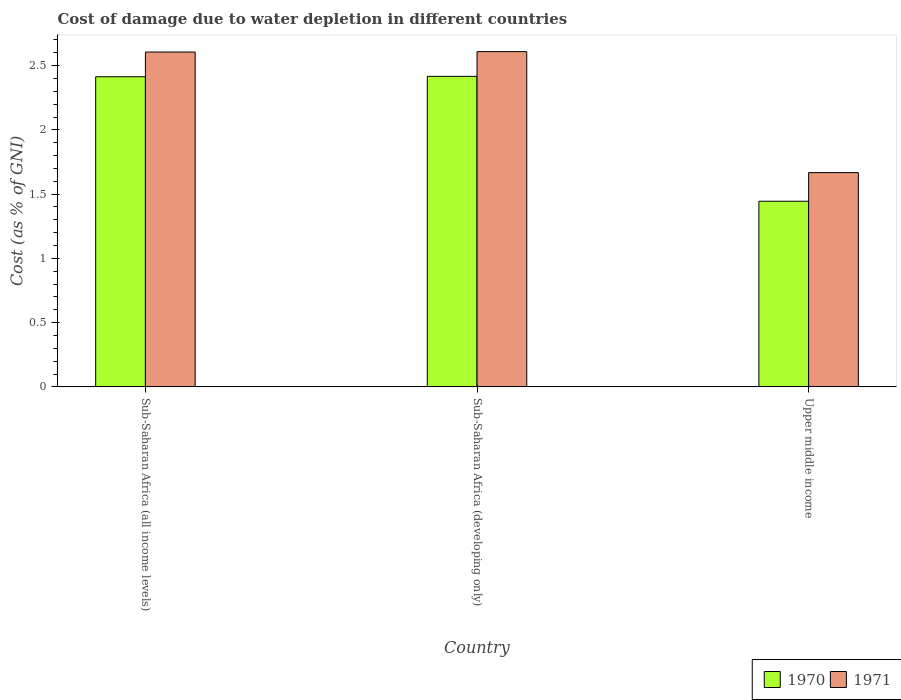How many groups of bars are there?
Keep it short and to the point. 3. Are the number of bars per tick equal to the number of legend labels?
Your answer should be compact. Yes. How many bars are there on the 2nd tick from the left?
Offer a very short reply. 2. What is the label of the 3rd group of bars from the left?
Your answer should be compact. Upper middle income. What is the cost of damage caused due to water depletion in 1971 in Sub-Saharan Africa (all income levels)?
Keep it short and to the point. 2.61. Across all countries, what is the maximum cost of damage caused due to water depletion in 1970?
Keep it short and to the point. 2.42. Across all countries, what is the minimum cost of damage caused due to water depletion in 1971?
Make the answer very short. 1.67. In which country was the cost of damage caused due to water depletion in 1970 maximum?
Provide a short and direct response. Sub-Saharan Africa (developing only). In which country was the cost of damage caused due to water depletion in 1971 minimum?
Offer a very short reply. Upper middle income. What is the total cost of damage caused due to water depletion in 1970 in the graph?
Make the answer very short. 6.27. What is the difference between the cost of damage caused due to water depletion in 1970 in Sub-Saharan Africa (all income levels) and that in Upper middle income?
Offer a very short reply. 0.97. What is the difference between the cost of damage caused due to water depletion in 1971 in Upper middle income and the cost of damage caused due to water depletion in 1970 in Sub-Saharan Africa (developing only)?
Provide a succinct answer. -0.75. What is the average cost of damage caused due to water depletion in 1970 per country?
Your answer should be compact. 2.09. What is the difference between the cost of damage caused due to water depletion of/in 1970 and cost of damage caused due to water depletion of/in 1971 in Sub-Saharan Africa (developing only)?
Your response must be concise. -0.19. In how many countries, is the cost of damage caused due to water depletion in 1971 greater than 1.8 %?
Keep it short and to the point. 2. What is the ratio of the cost of damage caused due to water depletion in 1971 in Sub-Saharan Africa (all income levels) to that in Sub-Saharan Africa (developing only)?
Ensure brevity in your answer.  1. Is the cost of damage caused due to water depletion in 1971 in Sub-Saharan Africa (all income levels) less than that in Upper middle income?
Provide a short and direct response. No. Is the difference between the cost of damage caused due to water depletion in 1970 in Sub-Saharan Africa (all income levels) and Sub-Saharan Africa (developing only) greater than the difference between the cost of damage caused due to water depletion in 1971 in Sub-Saharan Africa (all income levels) and Sub-Saharan Africa (developing only)?
Keep it short and to the point. Yes. What is the difference between the highest and the second highest cost of damage caused due to water depletion in 1971?
Your answer should be very brief. -0.94. What is the difference between the highest and the lowest cost of damage caused due to water depletion in 1970?
Offer a terse response. 0.97. What does the 1st bar from the left in Upper middle income represents?
Your answer should be compact. 1970. Are all the bars in the graph horizontal?
Offer a terse response. No. Are the values on the major ticks of Y-axis written in scientific E-notation?
Provide a short and direct response. No. What is the title of the graph?
Provide a short and direct response. Cost of damage due to water depletion in different countries. Does "1961" appear as one of the legend labels in the graph?
Make the answer very short. No. What is the label or title of the Y-axis?
Your response must be concise. Cost (as % of GNI). What is the Cost (as % of GNI) of 1970 in Sub-Saharan Africa (all income levels)?
Make the answer very short. 2.41. What is the Cost (as % of GNI) in 1971 in Sub-Saharan Africa (all income levels)?
Keep it short and to the point. 2.61. What is the Cost (as % of GNI) in 1970 in Sub-Saharan Africa (developing only)?
Your answer should be compact. 2.42. What is the Cost (as % of GNI) in 1971 in Sub-Saharan Africa (developing only)?
Provide a succinct answer. 2.61. What is the Cost (as % of GNI) in 1970 in Upper middle income?
Your answer should be compact. 1.44. What is the Cost (as % of GNI) in 1971 in Upper middle income?
Ensure brevity in your answer.  1.67. Across all countries, what is the maximum Cost (as % of GNI) of 1970?
Provide a short and direct response. 2.42. Across all countries, what is the maximum Cost (as % of GNI) of 1971?
Ensure brevity in your answer.  2.61. Across all countries, what is the minimum Cost (as % of GNI) in 1970?
Give a very brief answer. 1.44. Across all countries, what is the minimum Cost (as % of GNI) in 1971?
Make the answer very short. 1.67. What is the total Cost (as % of GNI) in 1970 in the graph?
Your answer should be very brief. 6.27. What is the total Cost (as % of GNI) in 1971 in the graph?
Provide a succinct answer. 6.88. What is the difference between the Cost (as % of GNI) of 1970 in Sub-Saharan Africa (all income levels) and that in Sub-Saharan Africa (developing only)?
Make the answer very short. -0. What is the difference between the Cost (as % of GNI) in 1971 in Sub-Saharan Africa (all income levels) and that in Sub-Saharan Africa (developing only)?
Provide a succinct answer. -0. What is the difference between the Cost (as % of GNI) of 1970 in Sub-Saharan Africa (all income levels) and that in Upper middle income?
Your response must be concise. 0.97. What is the difference between the Cost (as % of GNI) in 1971 in Sub-Saharan Africa (all income levels) and that in Upper middle income?
Make the answer very short. 0.94. What is the difference between the Cost (as % of GNI) in 1970 in Sub-Saharan Africa (developing only) and that in Upper middle income?
Offer a very short reply. 0.97. What is the difference between the Cost (as % of GNI) in 1971 in Sub-Saharan Africa (developing only) and that in Upper middle income?
Offer a terse response. 0.94. What is the difference between the Cost (as % of GNI) of 1970 in Sub-Saharan Africa (all income levels) and the Cost (as % of GNI) of 1971 in Sub-Saharan Africa (developing only)?
Ensure brevity in your answer.  -0.2. What is the difference between the Cost (as % of GNI) in 1970 in Sub-Saharan Africa (all income levels) and the Cost (as % of GNI) in 1971 in Upper middle income?
Make the answer very short. 0.75. What is the difference between the Cost (as % of GNI) in 1970 in Sub-Saharan Africa (developing only) and the Cost (as % of GNI) in 1971 in Upper middle income?
Your response must be concise. 0.75. What is the average Cost (as % of GNI) in 1970 per country?
Provide a succinct answer. 2.09. What is the average Cost (as % of GNI) in 1971 per country?
Provide a short and direct response. 2.29. What is the difference between the Cost (as % of GNI) in 1970 and Cost (as % of GNI) in 1971 in Sub-Saharan Africa (all income levels)?
Ensure brevity in your answer.  -0.19. What is the difference between the Cost (as % of GNI) in 1970 and Cost (as % of GNI) in 1971 in Sub-Saharan Africa (developing only)?
Your answer should be very brief. -0.19. What is the difference between the Cost (as % of GNI) of 1970 and Cost (as % of GNI) of 1971 in Upper middle income?
Your answer should be very brief. -0.22. What is the ratio of the Cost (as % of GNI) in 1970 in Sub-Saharan Africa (all income levels) to that in Upper middle income?
Give a very brief answer. 1.67. What is the ratio of the Cost (as % of GNI) of 1971 in Sub-Saharan Africa (all income levels) to that in Upper middle income?
Make the answer very short. 1.56. What is the ratio of the Cost (as % of GNI) in 1970 in Sub-Saharan Africa (developing only) to that in Upper middle income?
Make the answer very short. 1.67. What is the ratio of the Cost (as % of GNI) of 1971 in Sub-Saharan Africa (developing only) to that in Upper middle income?
Provide a short and direct response. 1.56. What is the difference between the highest and the second highest Cost (as % of GNI) of 1970?
Your answer should be compact. 0. What is the difference between the highest and the second highest Cost (as % of GNI) of 1971?
Keep it short and to the point. 0. What is the difference between the highest and the lowest Cost (as % of GNI) of 1970?
Keep it short and to the point. 0.97. What is the difference between the highest and the lowest Cost (as % of GNI) in 1971?
Offer a very short reply. 0.94. 